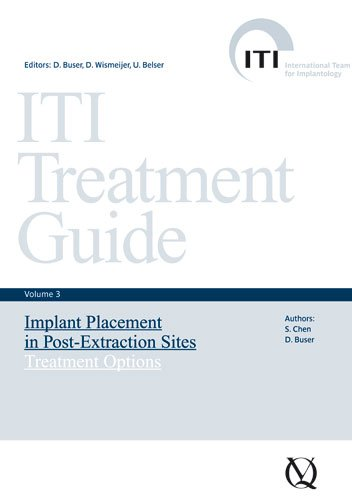Who wrote this book?
Answer the question using a single word or phrase. S. Chen What is the title of this book? ITI Treatment Guide, Volume 3: Implant Placement in Post-Extraction Sites: Treatment Options (ITI Treatment Guides) What type of book is this? Medical Books Is this a pharmaceutical book? Yes Is this a kids book? No 